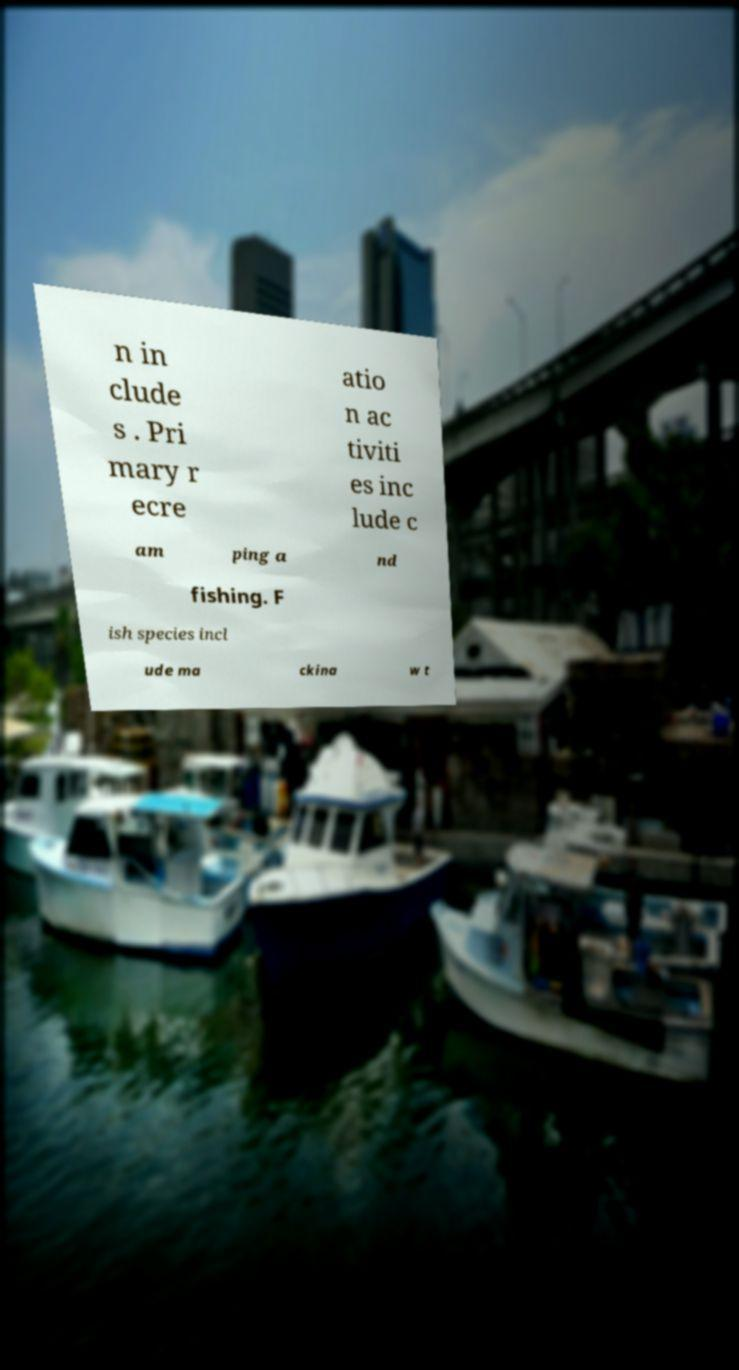Please identify and transcribe the text found in this image. n in clude s . Pri mary r ecre atio n ac tiviti es inc lude c am ping a nd fishing. F ish species incl ude ma ckina w t 